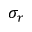Convert formula to latex. <formula><loc_0><loc_0><loc_500><loc_500>\sigma _ { r }</formula> 